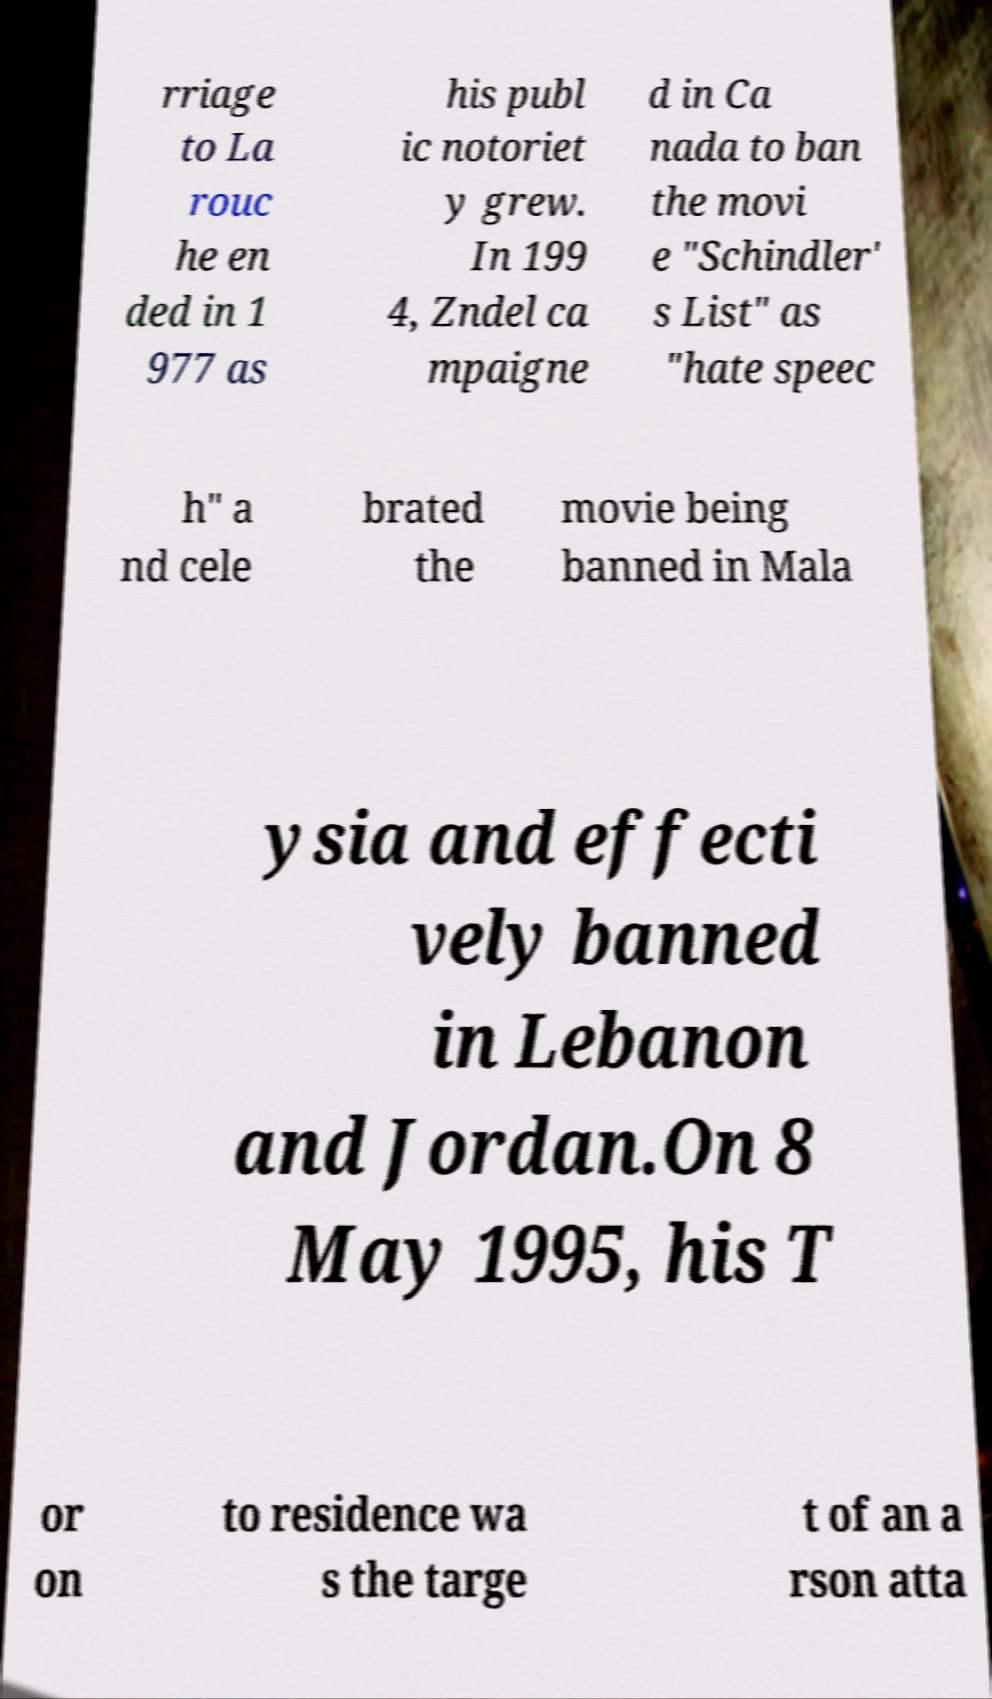What messages or text are displayed in this image? I need them in a readable, typed format. rriage to La rouc he en ded in 1 977 as his publ ic notoriet y grew. In 199 4, Zndel ca mpaigne d in Ca nada to ban the movi e "Schindler' s List" as "hate speec h" a nd cele brated the movie being banned in Mala ysia and effecti vely banned in Lebanon and Jordan.On 8 May 1995, his T or on to residence wa s the targe t of an a rson atta 